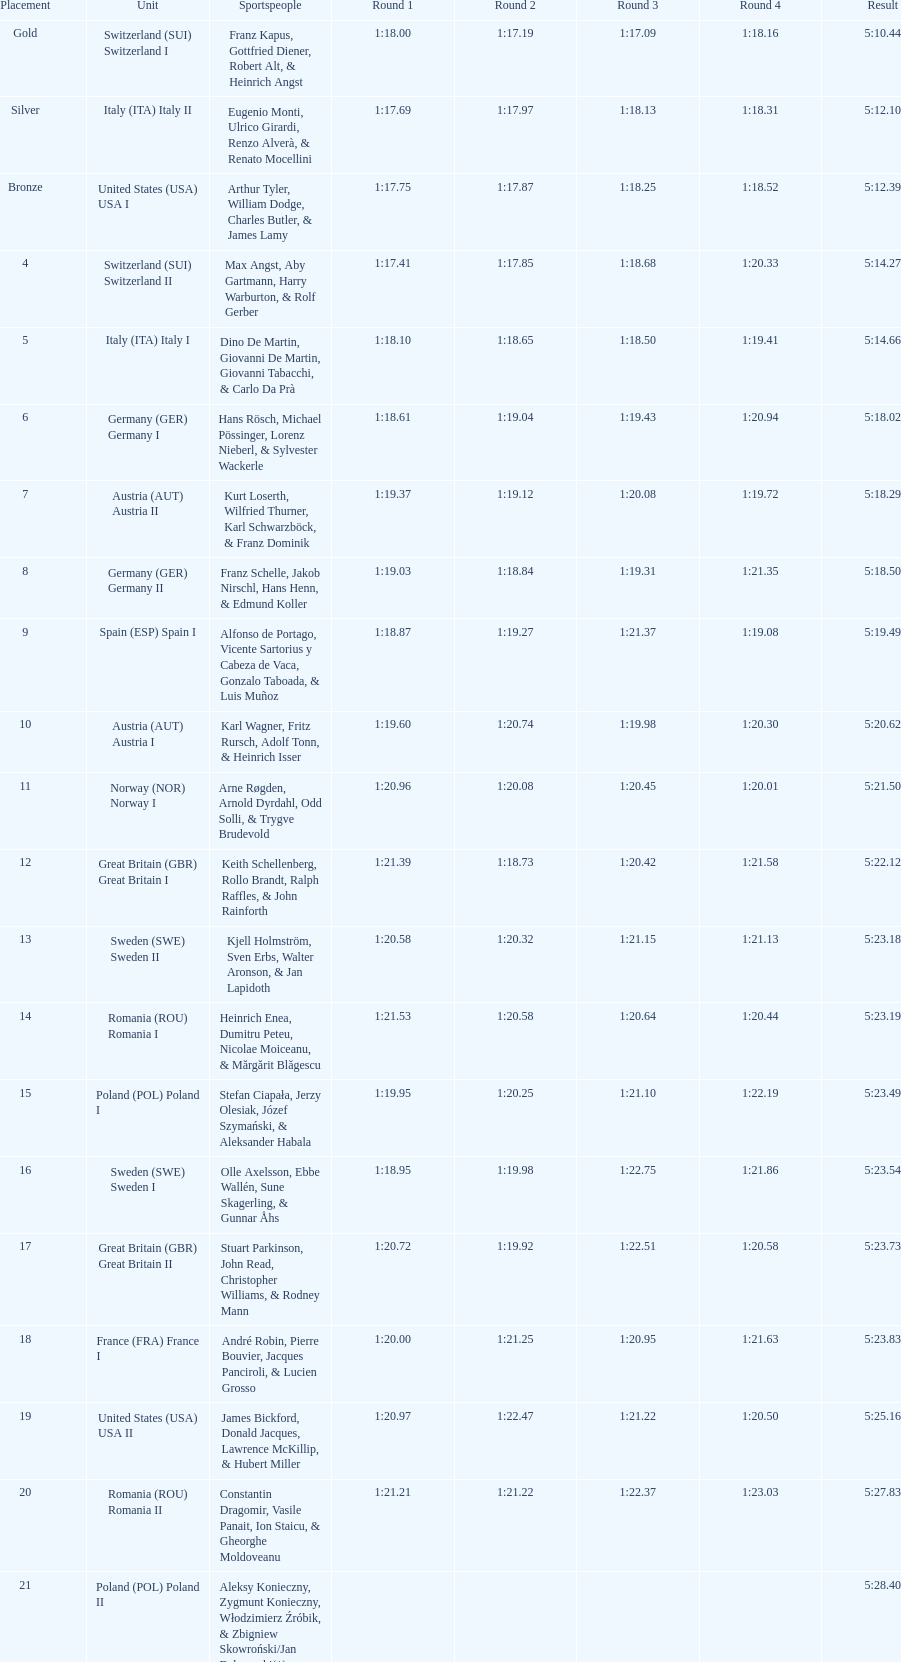Name a country that had 4 consecutive runs under 1:19. Switzerland. 